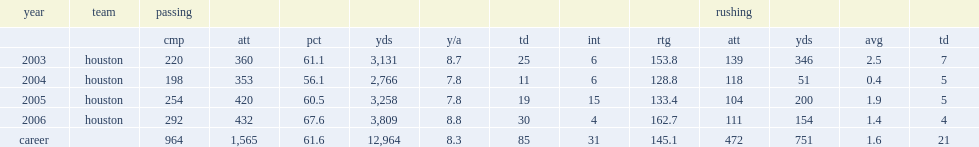How many passing yards did kolb finish the 2003 season with? 3131.0. How many touchdowns did kolb finish the 2003 season with? 25.0. How many passing interceptions did kolb finish the 2003 season with? 6.0. Can you give me this table as a dict? {'header': ['year', 'team', 'passing', '', '', '', '', '', '', '', 'rushing', '', '', ''], 'rows': [['', '', 'cmp', 'att', 'pct', 'yds', 'y/a', 'td', 'int', 'rtg', 'att', 'yds', 'avg', 'td'], ['2003', 'houston', '220', '360', '61.1', '3,131', '8.7', '25', '6', '153.8', '139', '346', '2.5', '7'], ['2004', 'houston', '198', '353', '56.1', '2,766', '7.8', '11', '6', '128.8', '118', '51', '0.4', '5'], ['2005', 'houston', '254', '420', '60.5', '3,258', '7.8', '19', '15', '133.4', '104', '200', '1.9', '5'], ['2006', 'houston', '292', '432', '67.6', '3,809', '8.8', '30', '4', '162.7', '111', '154', '1.4', '4'], ['career', '', '964', '1,565', '61.6', '12,964', '8.3', '85', '31', '145.1', '472', '751', '1.6', '21']]} 